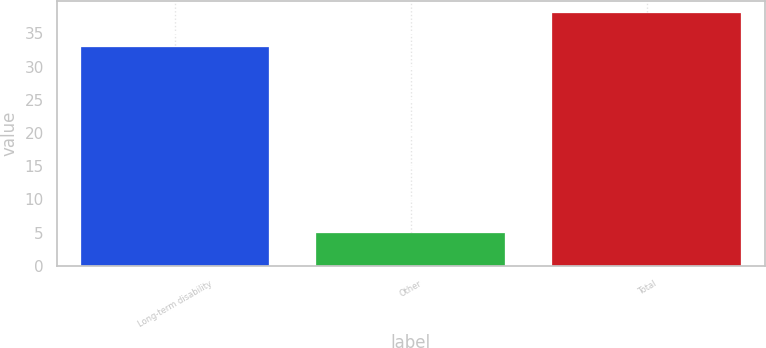Convert chart. <chart><loc_0><loc_0><loc_500><loc_500><bar_chart><fcel>Long-term disability<fcel>Other<fcel>Total<nl><fcel>33<fcel>5<fcel>38<nl></chart> 